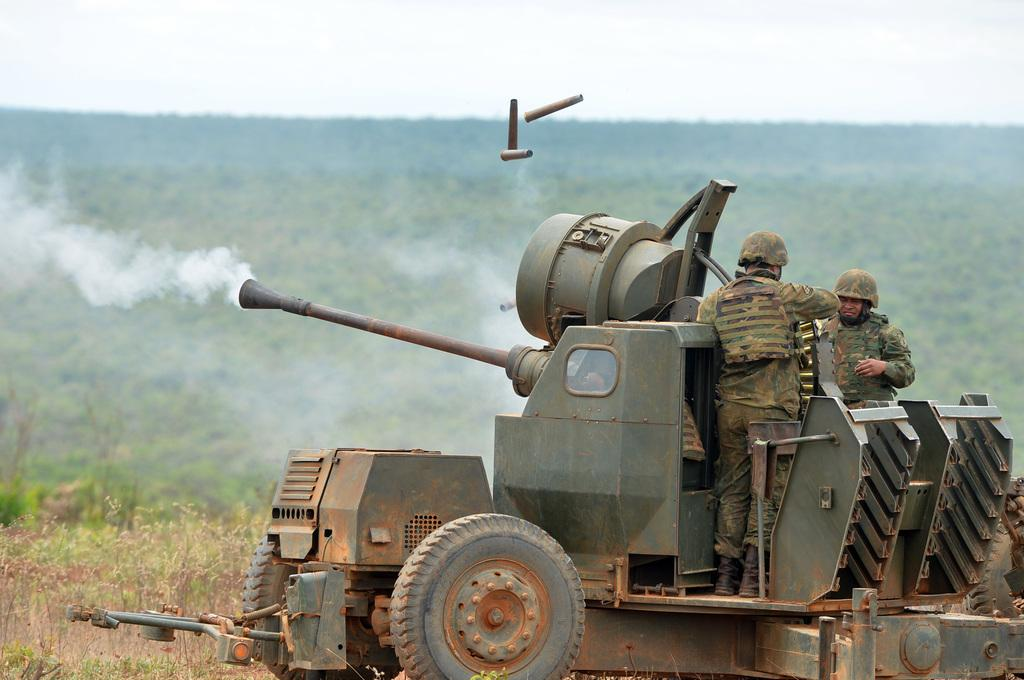What is the main subject of the image? The main subject of the image is a military tanker. Are there any people present in the image? Yes, two military soldiers are standing on top of the tanker. Can you describe the background of the image? The background is blurred, but trees are visible in the background. What type of patch can be seen on the collar of the military soldiers in the image? There is no patch visible on the collar of the military soldiers in the image. Is there a prison in the background of the image? There is no prison present in the image; the background features a blurred scene with trees. 